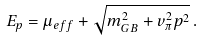Convert formula to latex. <formula><loc_0><loc_0><loc_500><loc_500>E _ { p } = \mu _ { e f f } + \sqrt { m _ { G B } ^ { 2 } + v _ { \pi } ^ { 2 } p ^ { 2 } } \, .</formula> 